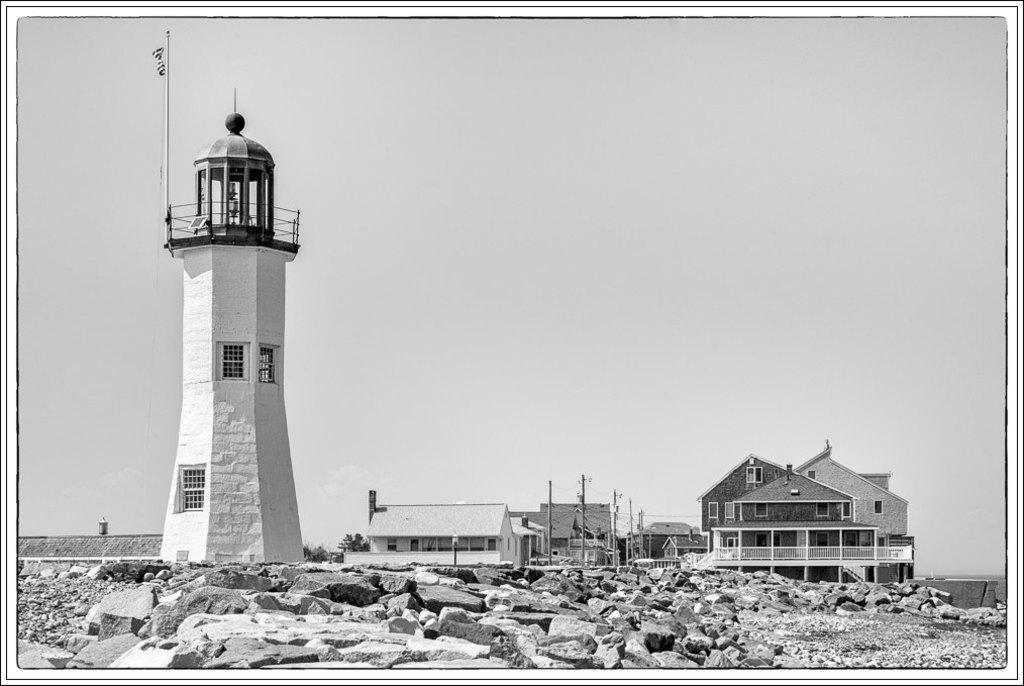How would you summarize this image in a sentence or two? This is a black and white image. In this image there is a lighthouse with railings, pillars and windows. On the ground there are stones. In the back there are buildings, electric poles and sky. 